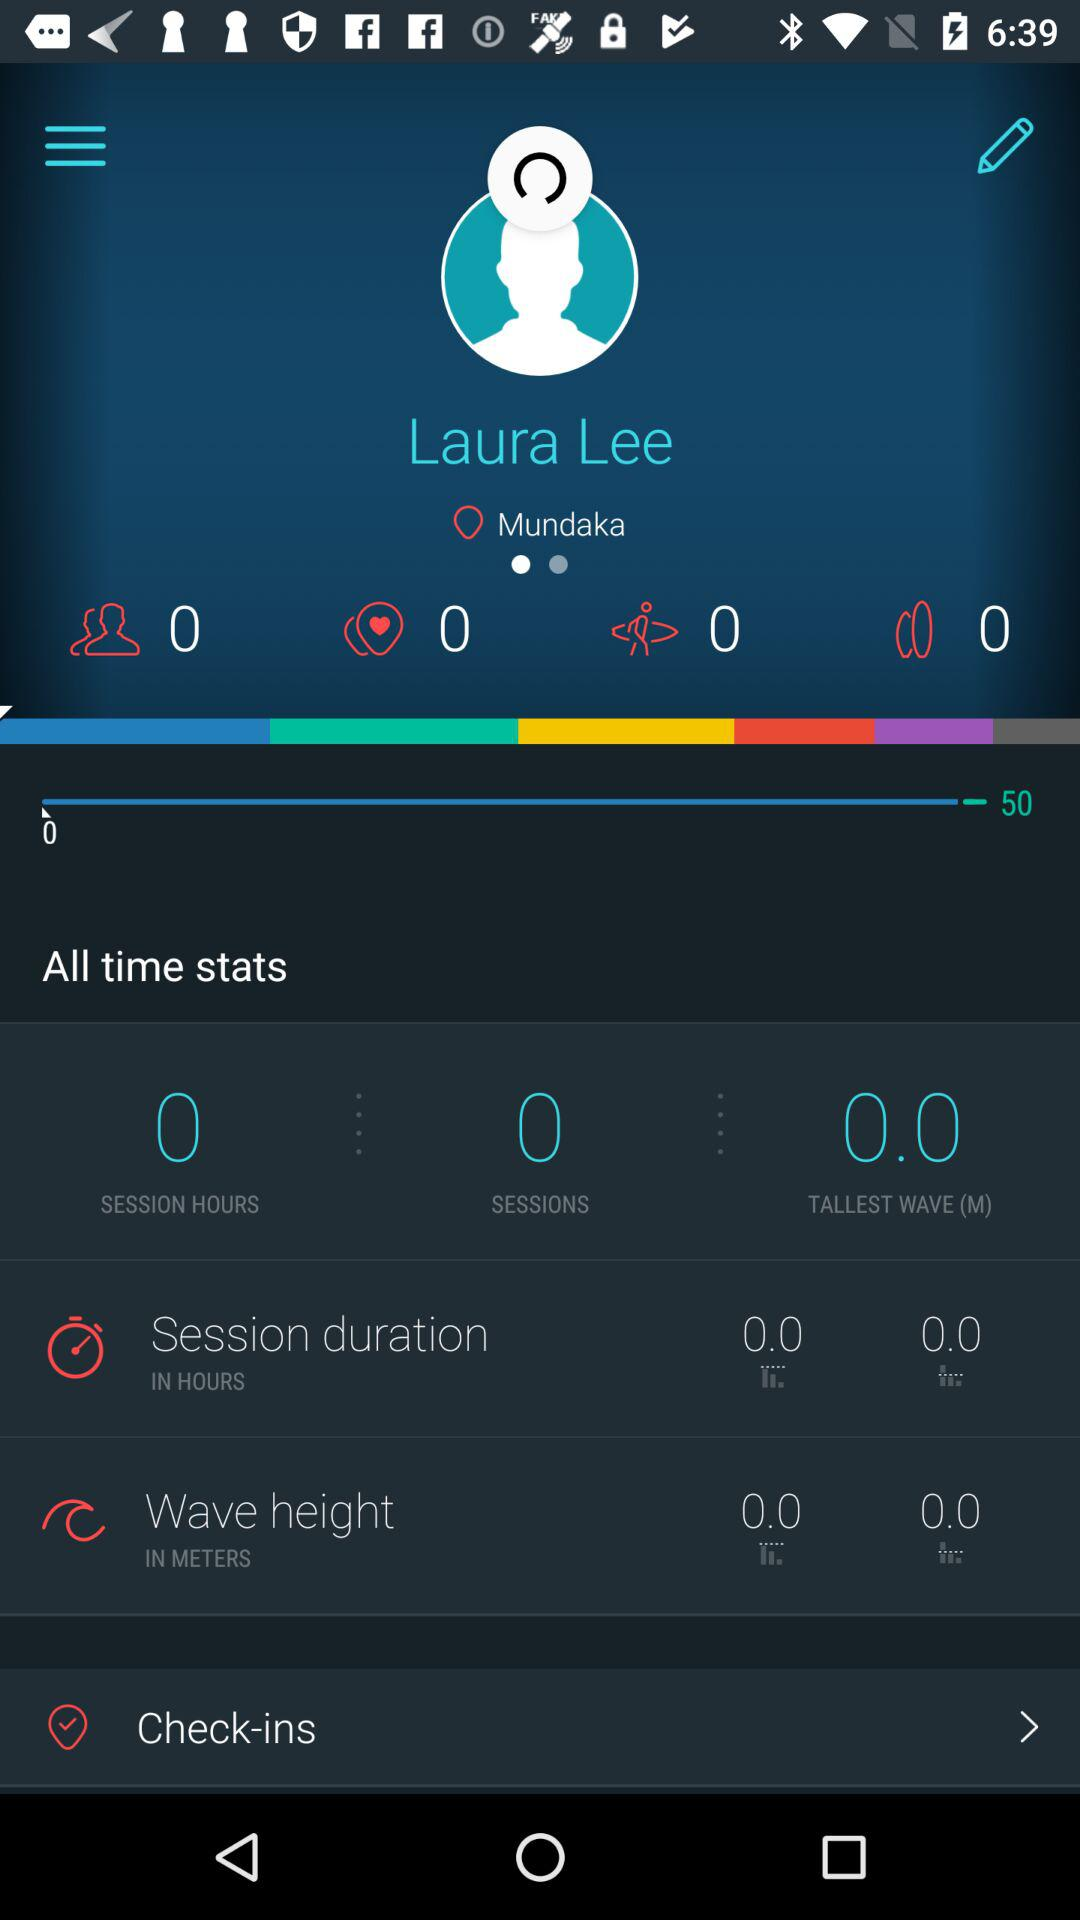What is the location of the user? The location is Mundaka. 